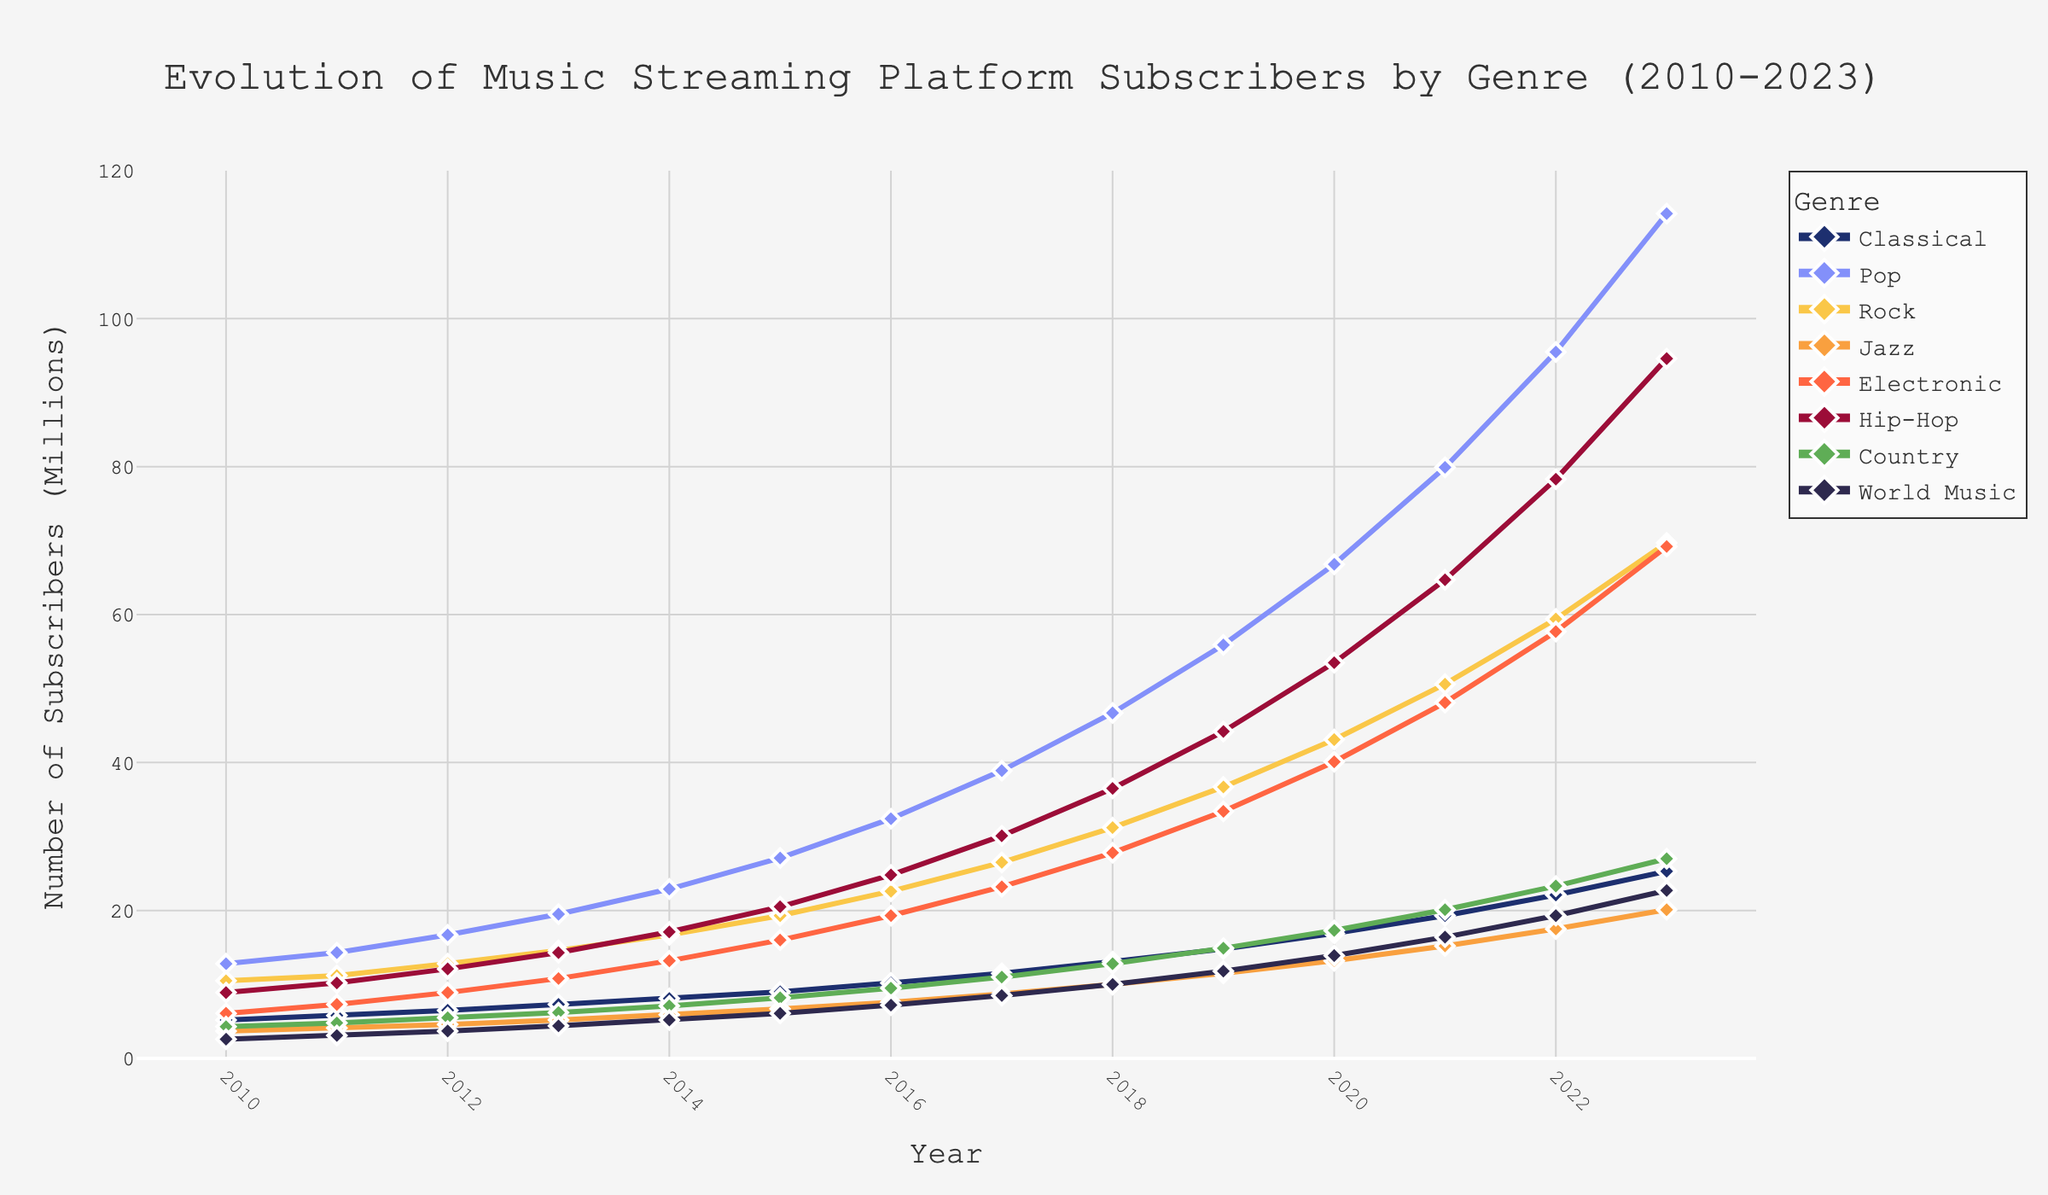When did the Pop genre surpass 50 million subscribers? Referring to the line chart, look at the Pop genre's trajectory and identify the year when its subscriber count exceeds 50 million.
Answer: 2019 Which genre has the smallest number of subscribers in 2023? In the figure, identify the genre with the lowest endpoint on the right side of the chart for the year 2023.
Answer: World Music Calculate the total number of Classical subscribers from 2010 to 2023. Sum up the subscriber numbers for the Classical genre across all provided years: 5.2 + 5.8 + 6.5 + 7.3 + 8.1 + 9.0 + 10.2 + 11.5 + 13.1 + 14.8 + 16.9 + 19.3 + 22.1 + 25.3.
Answer: 175 How does Jazz's growth rate from 2010 to 2023 compare to Rock's growth rate over the same period? Calculate the difference between the subscriber numbers in 2023 and 2010 for both Jazz and Rock, then compare these differences: (20.1 - 3.7) for Jazz and (69.7 - 10.5) for Rock.
Answer: Jazz: 16.4, Rock: 59.2 Identify which genre had the fastest growth between 2017 and 2018. Calculate the increase in subscriber numbers for each genre between 2017 and 2018 and then identify the genre with the largest increase.
Answer: Pop Which genre saw the smallest increase in subscriptions from 2013 to 2014? Calculate the difference in subscribers for each genre between 2013 and 2014 and identify the smallest value.
Answer: World Music What is the average number of subscribers for the Electronic genre from 2010 to 2023? Sum the subscriber numbers for the Electronic genre across all years and divide by the number of years: (6.1 + 7.3 + 8.9 + 10.8 + 13.2 + 16.0 + 19.3 + 23.2 + 27.8 + 33.4 + 40.1 + 48.1 + 57.7 + 69.2) / 14.
Answer: 26.76 Compare the number of subscribers in the Classical genre to Hip-Hop in 2020. Locate the subscriber numbers for both Classical and Hip-Hop genres in 2020 and compare their values.
Answer: Classical: 16.9, Hip-Hop: 53.5 In which year did Country subscribers reach 20 million? Identify the year from the line chart when the Country genre crosses the 20 million subscriber mark.
Answer: 2021 